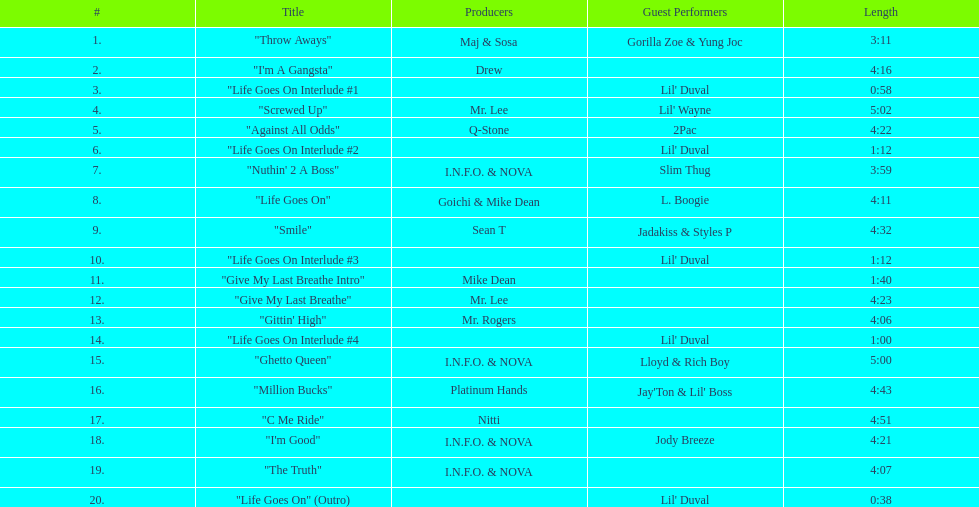Which tracks feature the same producer(s) in consecutive order on this album? "I'm Good", "The Truth". 